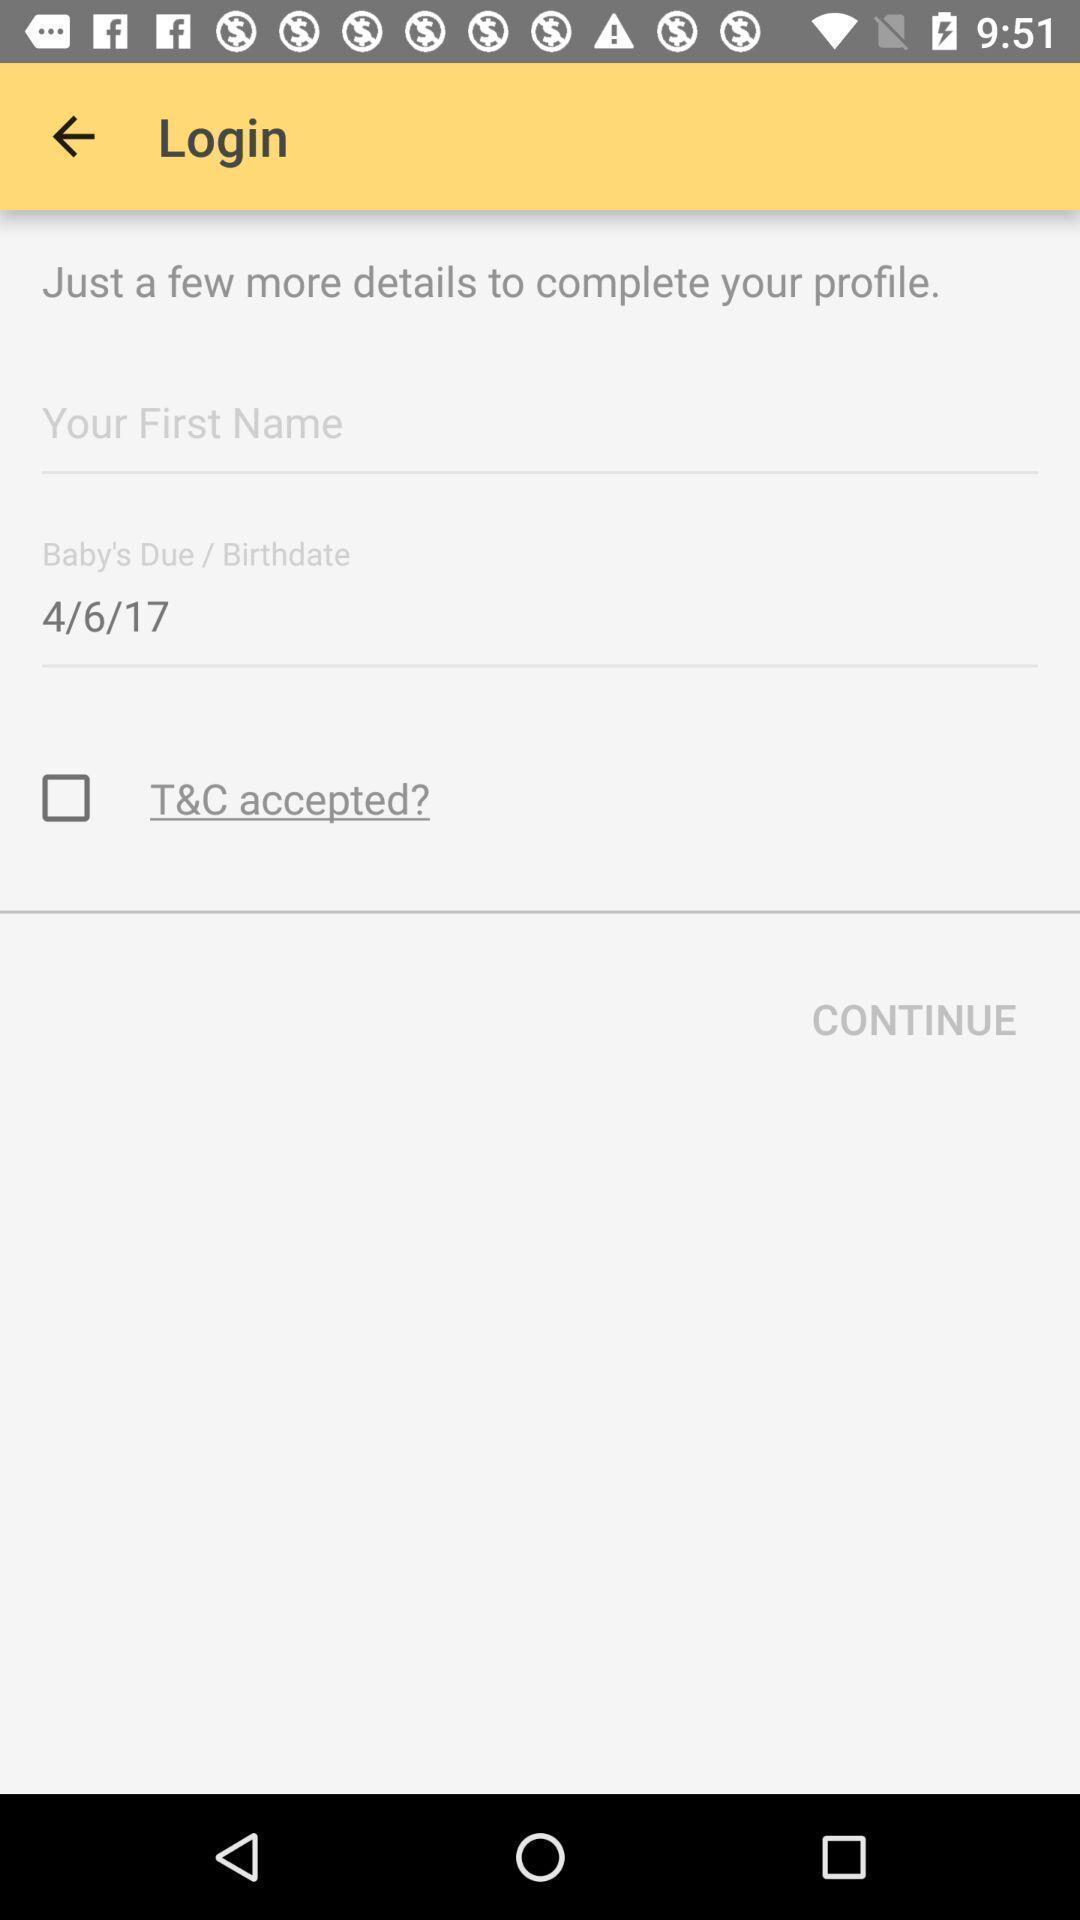Explain the elements present in this screenshot. Login page. 